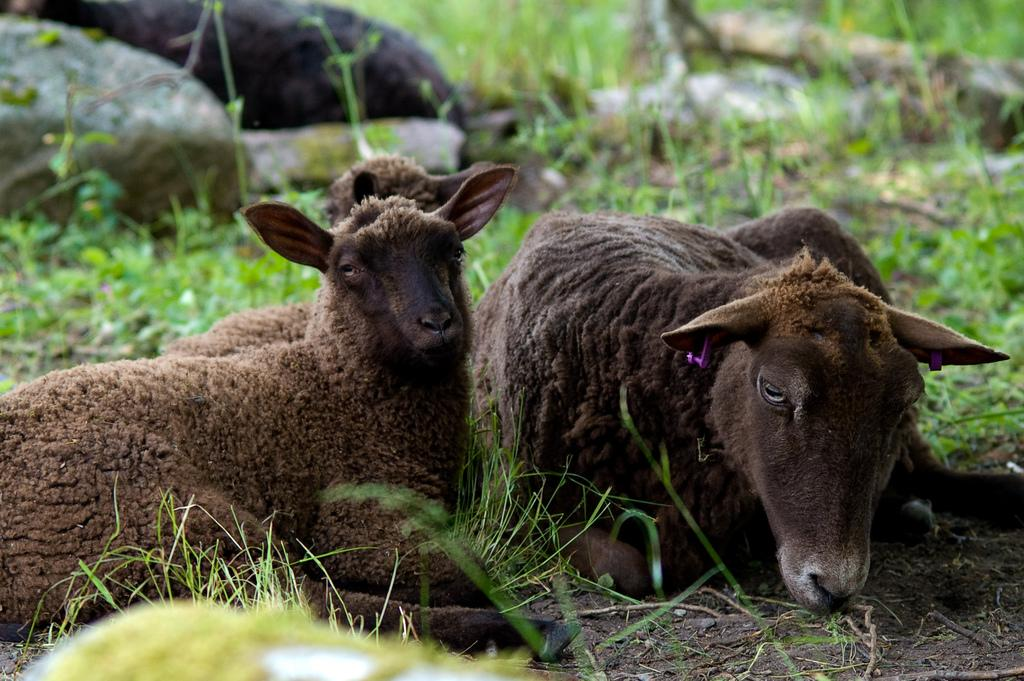What are the animals in the image doing? The animals are sitting on the ground. What can be seen in the background of the image? There is a stone, grass, and another animal in the background. What type of vegetation is present in the background? There is grass in the background. What else can be seen on the ground in the background? There are other objects on the ground in the background. What type of gate can be seen in the image? There is no gate present in the image. What part of the animals is visible in the image? The animals are sitting on the ground, so their legs and bodies are visible, but no specific part is being highlighted. 